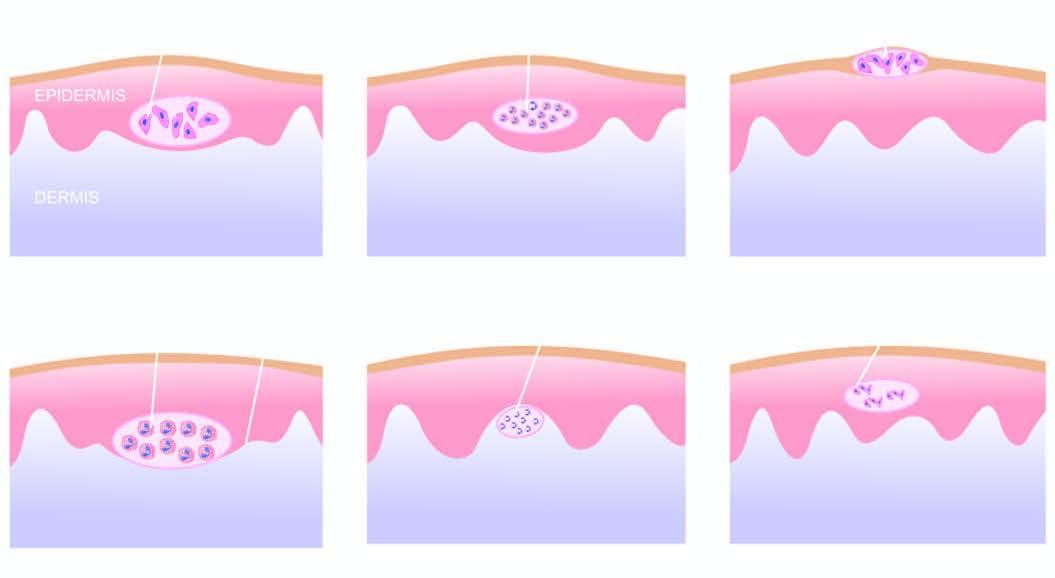what shows necrotic keratinocytes and inflammatory cells?
Answer the question using a single word or phrase. Affected area 